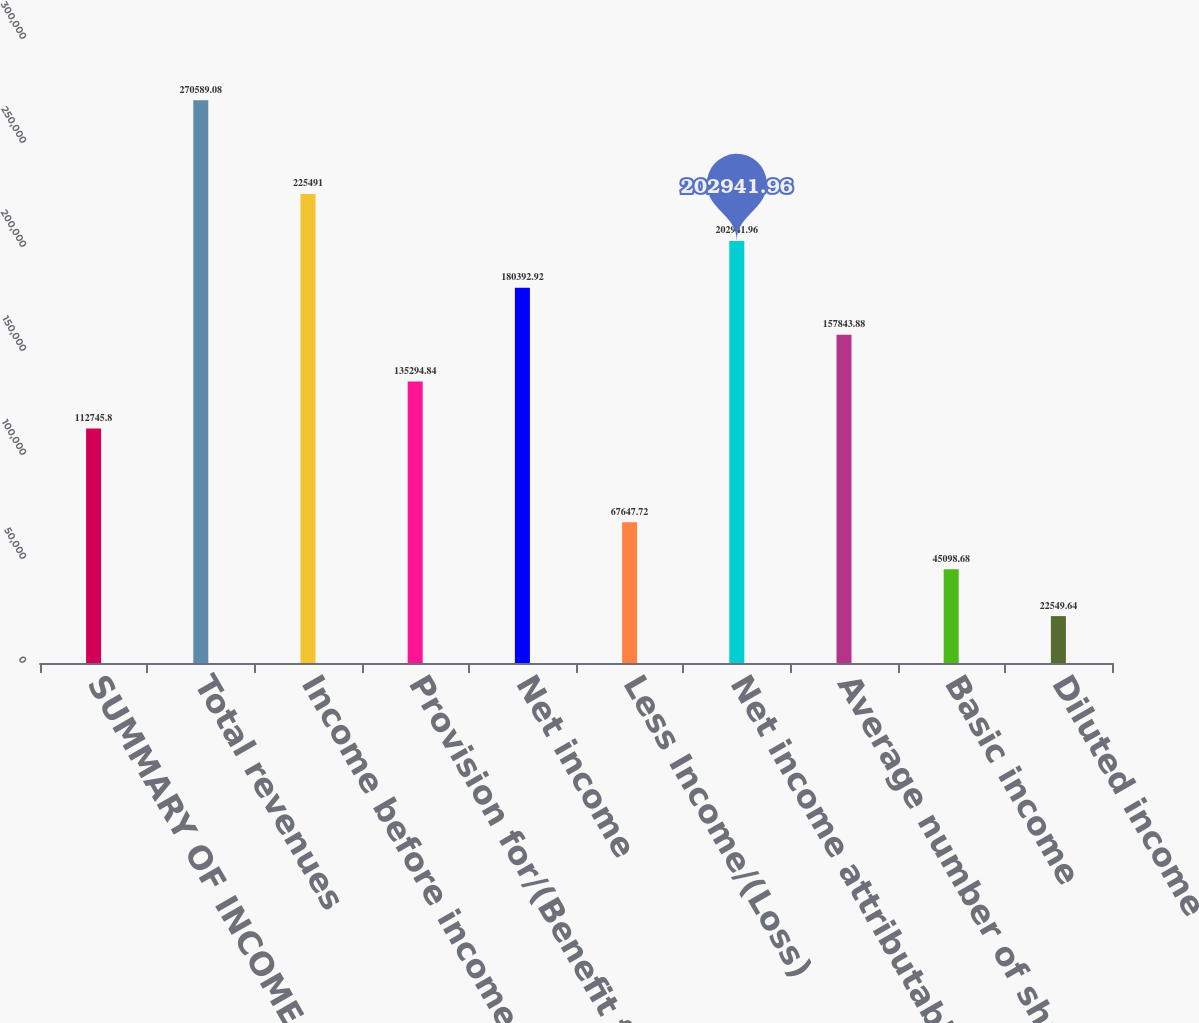Convert chart. <chart><loc_0><loc_0><loc_500><loc_500><bar_chart><fcel>SUMMARY OF INCOME<fcel>Total revenues<fcel>Income before income taxes<fcel>Provision for/(Benefit from)<fcel>Net income<fcel>Less Income/(Loss)<fcel>Net income attributable to<fcel>Average number of shares of<fcel>Basic income<fcel>Diluted income<nl><fcel>112746<fcel>270589<fcel>225491<fcel>135295<fcel>180393<fcel>67647.7<fcel>202942<fcel>157844<fcel>45098.7<fcel>22549.6<nl></chart> 